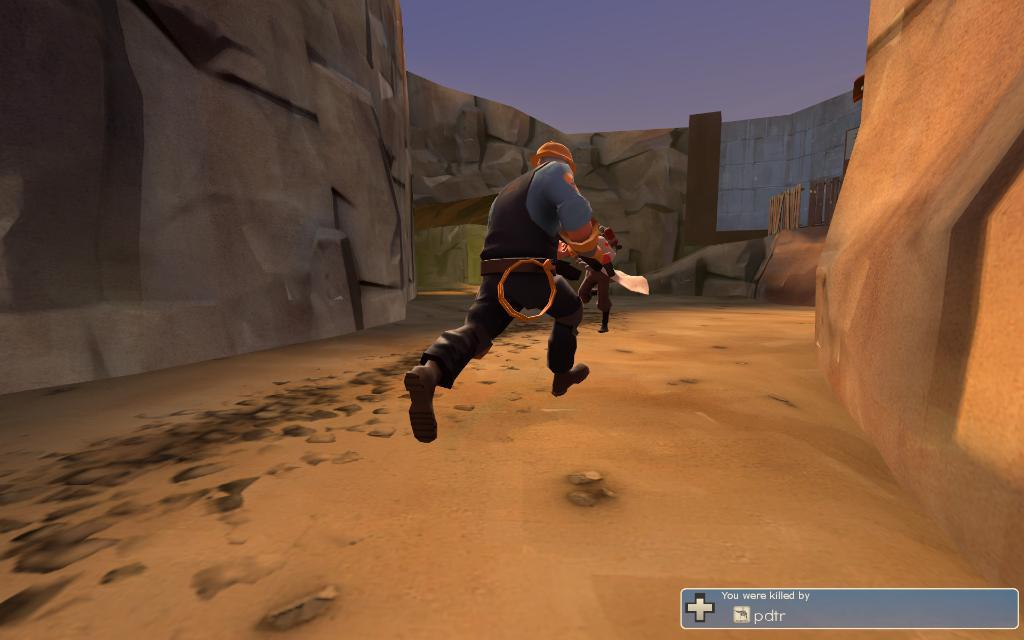What is the man in the image doing? The man is running in the image. What can be seen in the background behind the man? Rock walls are present behind the man. Is there any text visible in the image? Yes, there is some text in the bottom right corner of the image. What type of brass instrument is the man playing while running in the image? There is no brass instrument present in the image; the man is simply running. 